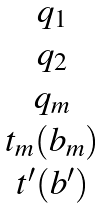Convert formula to latex. <formula><loc_0><loc_0><loc_500><loc_500>\begin{matrix} q _ { 1 } \\ q _ { 2 } \\ q _ { m } \\ t _ { m } ( b _ { m } ) \\ t ^ { \prime } ( b ^ { \prime } ) \end{matrix}</formula> 